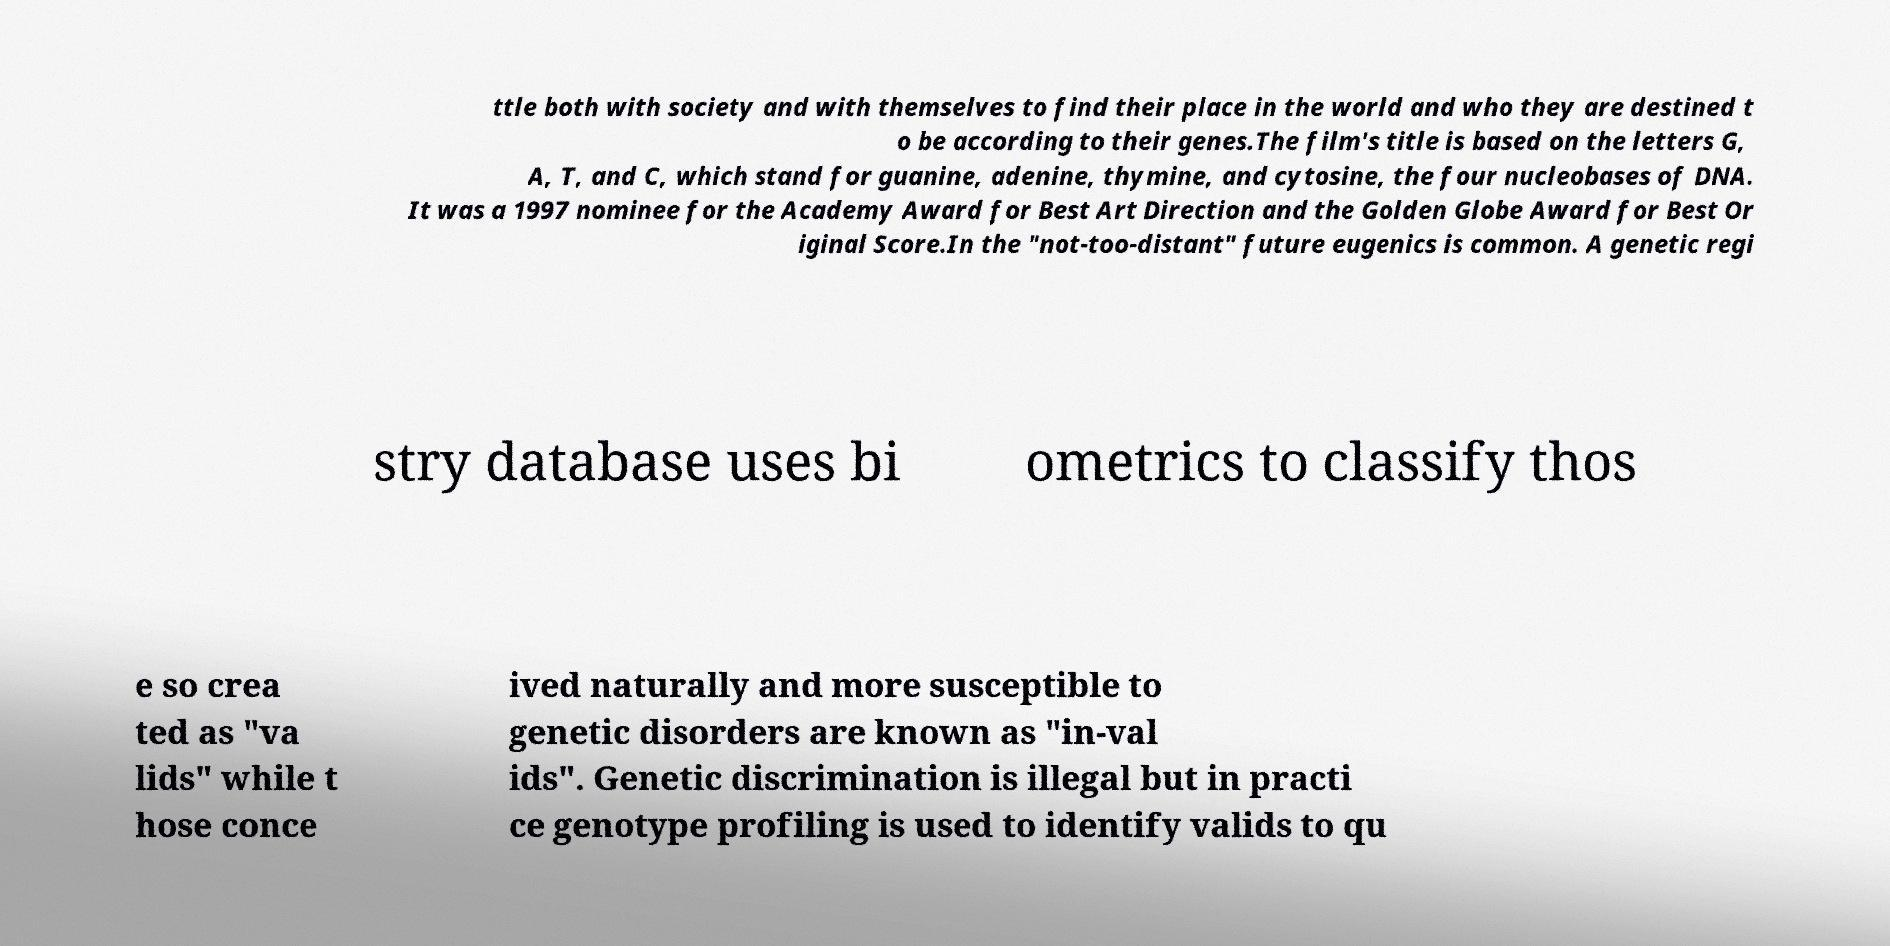Can you read and provide the text displayed in the image?This photo seems to have some interesting text. Can you extract and type it out for me? ttle both with society and with themselves to find their place in the world and who they are destined t o be according to their genes.The film's title is based on the letters G, A, T, and C, which stand for guanine, adenine, thymine, and cytosine, the four nucleobases of DNA. It was a 1997 nominee for the Academy Award for Best Art Direction and the Golden Globe Award for Best Or iginal Score.In the "not-too-distant" future eugenics is common. A genetic regi stry database uses bi ometrics to classify thos e so crea ted as "va lids" while t hose conce ived naturally and more susceptible to genetic disorders are known as "in-val ids". Genetic discrimination is illegal but in practi ce genotype profiling is used to identify valids to qu 